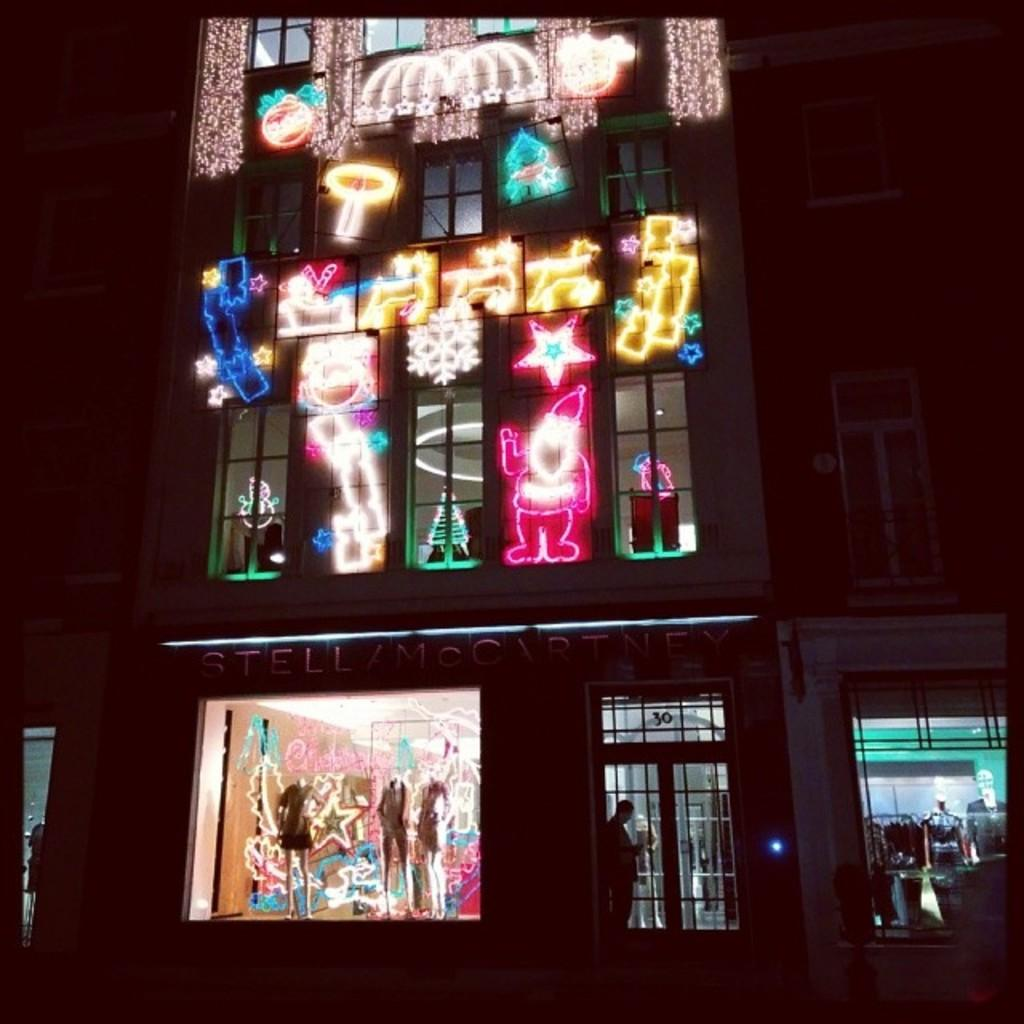What type of structure is visible in the image? There is a building in the image. What can be found inside the building? There are stores in the building. Can you describe a specific feature of the building? There is a door in the image. Who or what can be seen in the image? There are people and mannequins in the image. What is used for displaying information or advertisements in the image? There is a board in the image. What allows natural light to enter the building? There are windows in the image. What is used for decoration or illumination in the image? Decorating lights are present in the image. What is a part of the building's structure that separates different areas? There is a wall in the image. What type of cheese is being served in the image? There is no cheese present in the image. What kind of oatmeal is being prepared in the image? There is no oatmeal present in the image. Can you describe the kitty's behavior in the image? There is no kitty present in the image. 